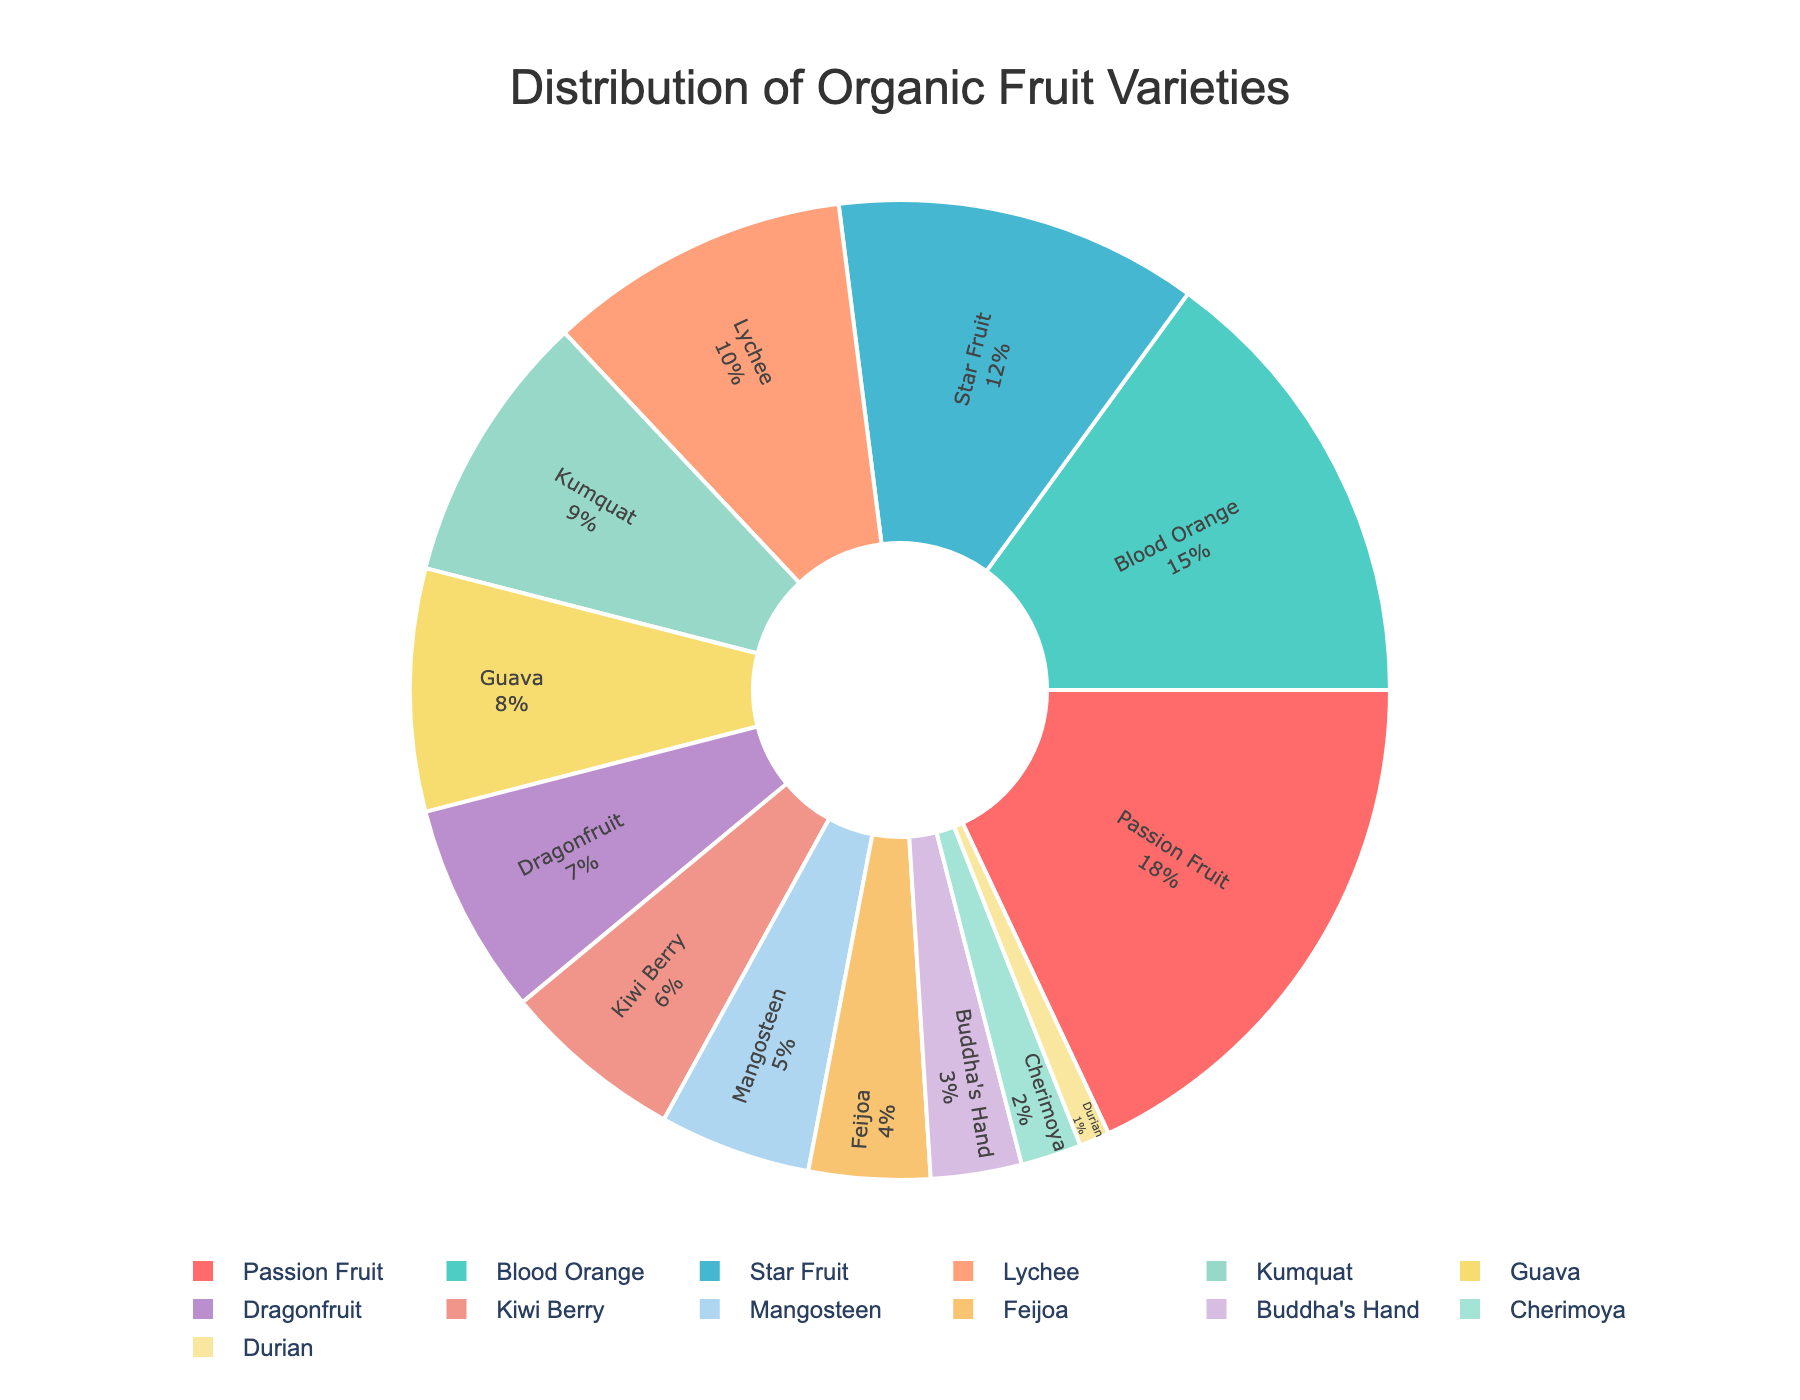Which fruit variety has the highest percentage? Look at the pie chart and identify the fruit variety with the highest percentage label. "Passion Fruit" has the largest segment.
Answer: Passion Fruit What is the total percentage of Blood Orange and Star Fruit combined? Find the percentages for Blood Orange and Star Fruit, then sum them up. Blood Orange: 15%, Star Fruit: 12%, Total = 15 + 12.
Answer: 27% Which fruit varieties collectively make up less than 10% each? Identify all fruit varieties with segments smaller than 10%. These are Lychee, Kumquat, Guava, Dragonfruit, Kiwi Berry, Mangosteen, Feijoa, Buddha's Hand, Cherimoya, and Durian.
Answer: Lychee, Kumquat, Guava, Dragonfruit, Kiwi Berry, Mangosteen, Feijoa, Buddha's Hand, Cherimoya, Durian Is the segment for Guava greater than the segment for Durian? Compare the percentages of Guava (8%) and Durian (1%). Since 8 is greater than 1, Guava has a larger segment.
Answer: Yes What is the combined percentage of the least common fruit varieties, and how many are there? Identify all varieties with a percentage less than 5% and sum their values. These are Feijoa (4%), Buddha's Hand (3%), Cherimoya (2%), and Durian (1%). Total = 4 + 3 + 2 + 1 = 10%. Number of varieties = 4.
Answer: 10%, 4 Which fruit variety has a smaller percentage than Kiwi Berry but larger than Durian? Identify the percentages of Kiwi Berry (6%) and Durian (1%), then find the variety with a percentage between 1% and 6%. Mangosteen (5%) fits this criterion.
Answer: Mangosteen What percentage do the top three fruit varieties collectively contribute? Identify the top three varieties by percentage: Passion Fruit (18%), Blood Orange (15%), and Star Fruit (12%). Sum them up, 18 + 15 + 12 = 45.
Answer: 45% Compare the percentage of Lychee to that of Kiwi Berry. Which one is greater? Compare the percentage of Lychee (10%) and Kiwi Berry (6%). Lychee has a higher percentage than Kiwi Berry.
Answer: Lychee What fraction of the total does Dragonfruit represent, and how does this proportion compare to Kumquat? Find the percentage for Dragonfruit (7%) and Kumquat (9%). Dragonfruit's fraction is 7/100 and Kumquat is 9/100. Therefore, Dragonfruit's fraction (7%) is less than Kumquat's fraction (9%).
Answer: 7%, less What is the difference in percentage between the highest and lowest represented fruit varieties? Identify the highest percentage (Passion Fruit, 18%) and the lowest percentage (Durian, 1%). Subtract the lowest from the highest, 18 - 1 = 17.
Answer: 17% 